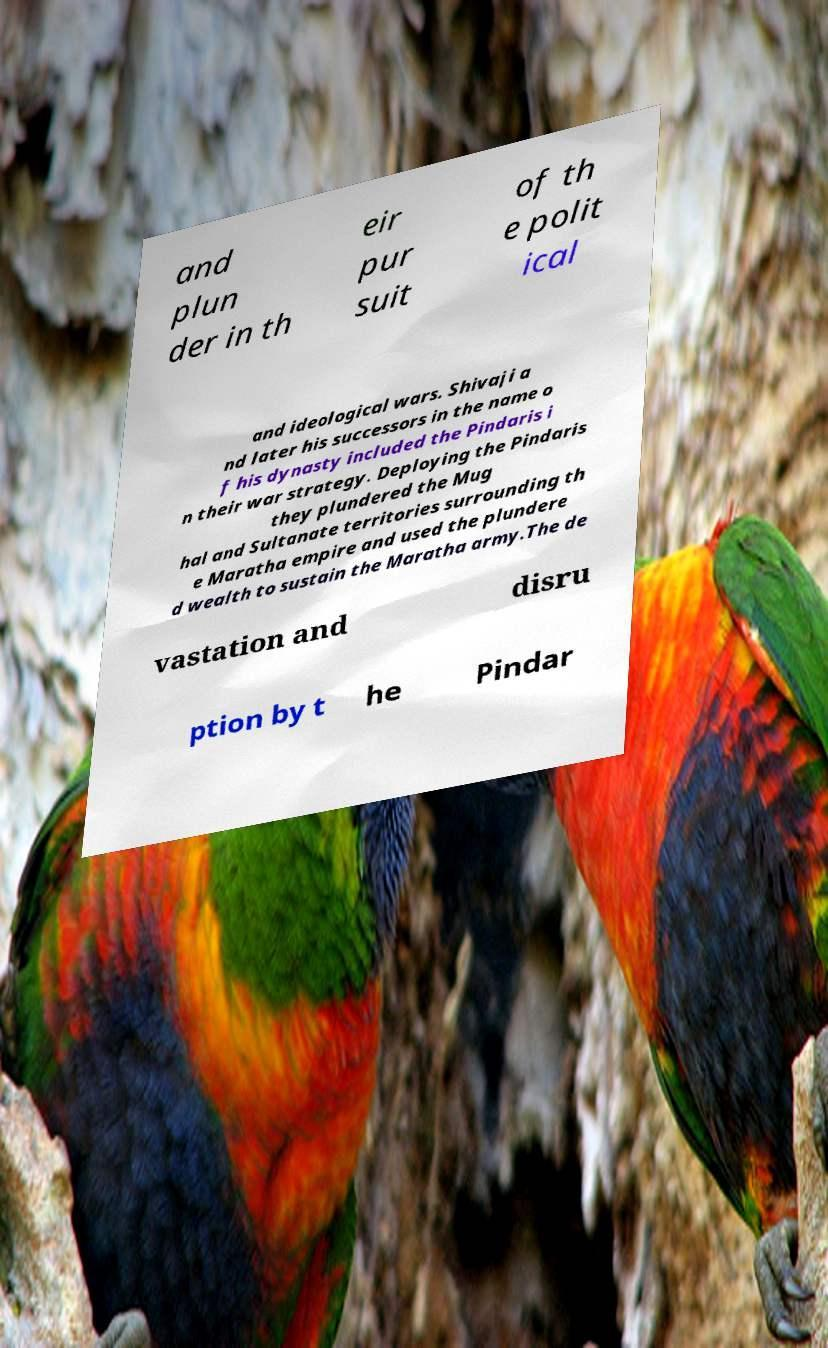What messages or text are displayed in this image? I need them in a readable, typed format. and plun der in th eir pur suit of th e polit ical and ideological wars. Shivaji a nd later his successors in the name o f his dynasty included the Pindaris i n their war strategy. Deploying the Pindaris they plundered the Mug hal and Sultanate territories surrounding th e Maratha empire and used the plundere d wealth to sustain the Maratha army.The de vastation and disru ption by t he Pindar 